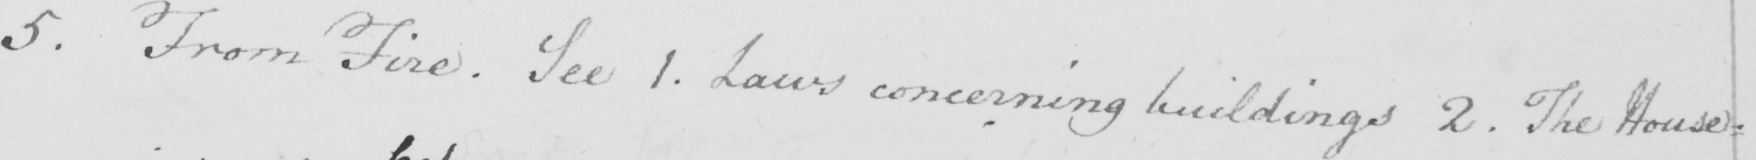Can you tell me what this handwritten text says? 5 . From Fire . See 1 . Laws concerning buildings 2 . The House : 